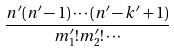<formula> <loc_0><loc_0><loc_500><loc_500>\frac { n ^ { \prime } ( n ^ { \prime } - 1 ) \cdots ( n ^ { \prime } - k ^ { \prime } + 1 ) } { m ^ { \prime } _ { 1 } ! m ^ { \prime } _ { 2 } ! \cdots }</formula> 